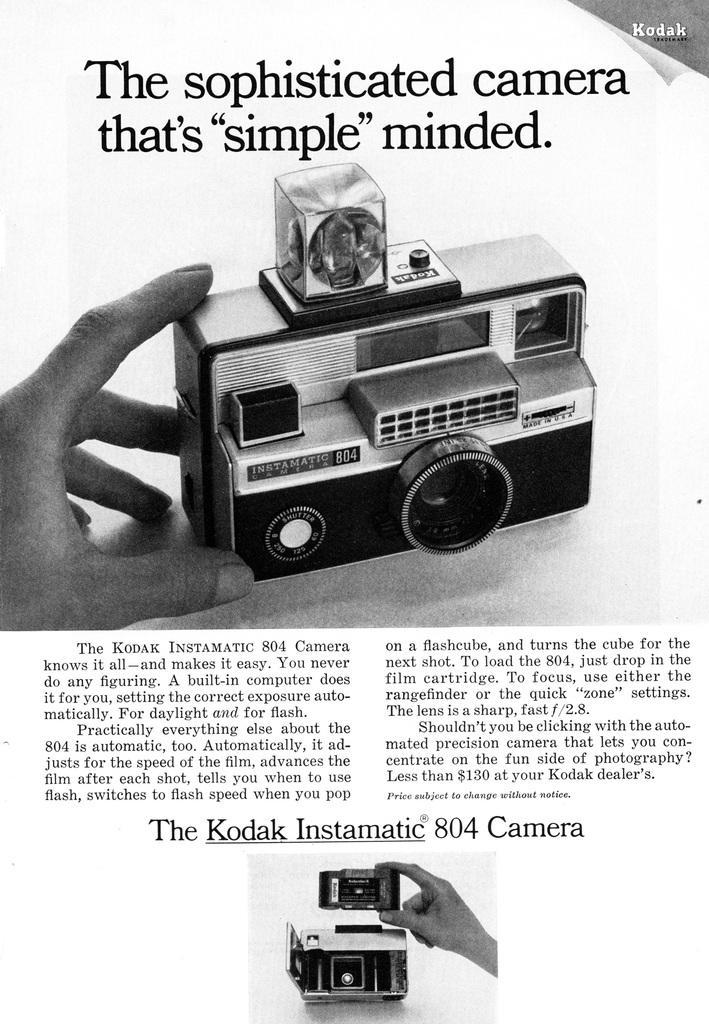Describe this image in one or two sentences. This is a black and white image. In this image we can see a person holding the camera and there is text at the bottom and top. 